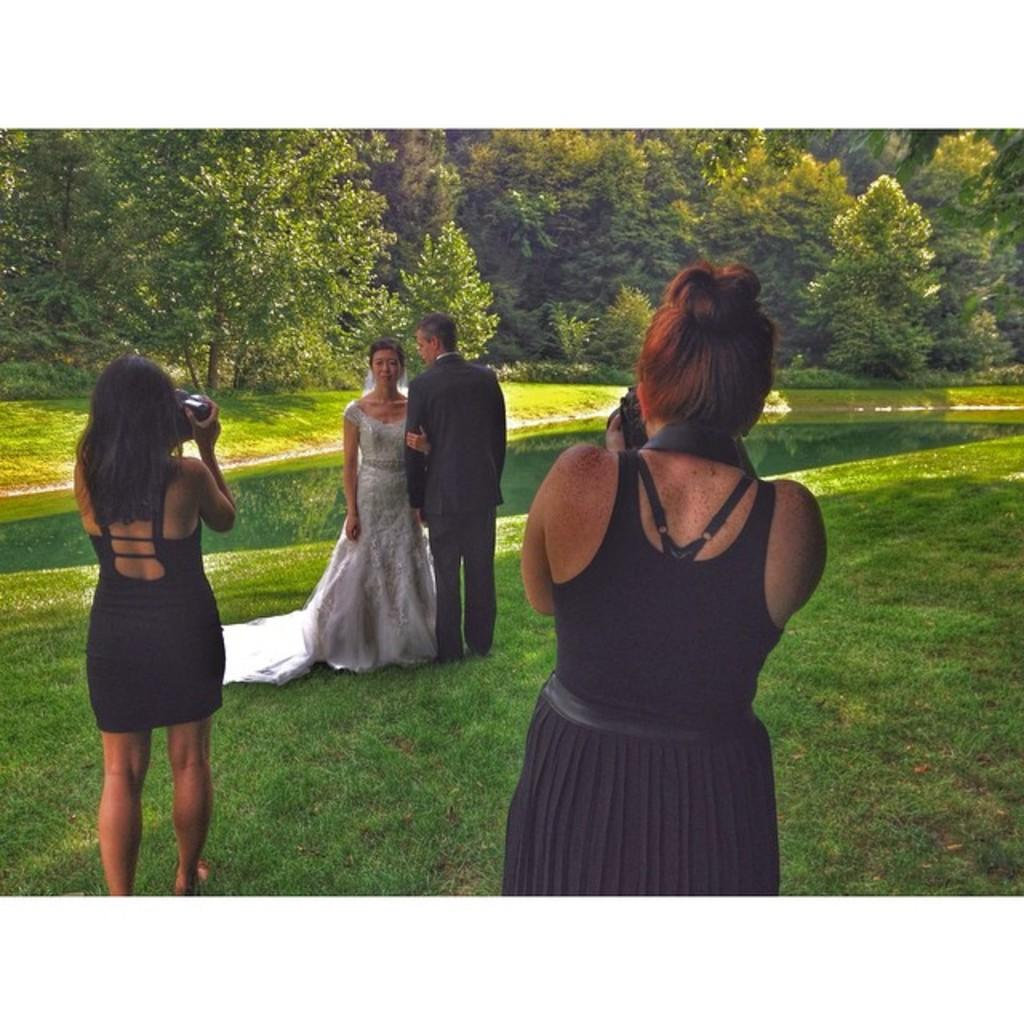How many people are in the image? There is a group of people in the image, but the exact number is not specified. What is the position of the people in the image? The people are standing on the ground in the image. What can be seen in the background of the image? There is water and trees visible in the background of the image. What type of copper material is being used by the people in the image? There is no copper material present in the image. Are the people wearing socks in the image? The image does not provide information about the people's footwear, so it cannot be determined if they are wearing socks. 